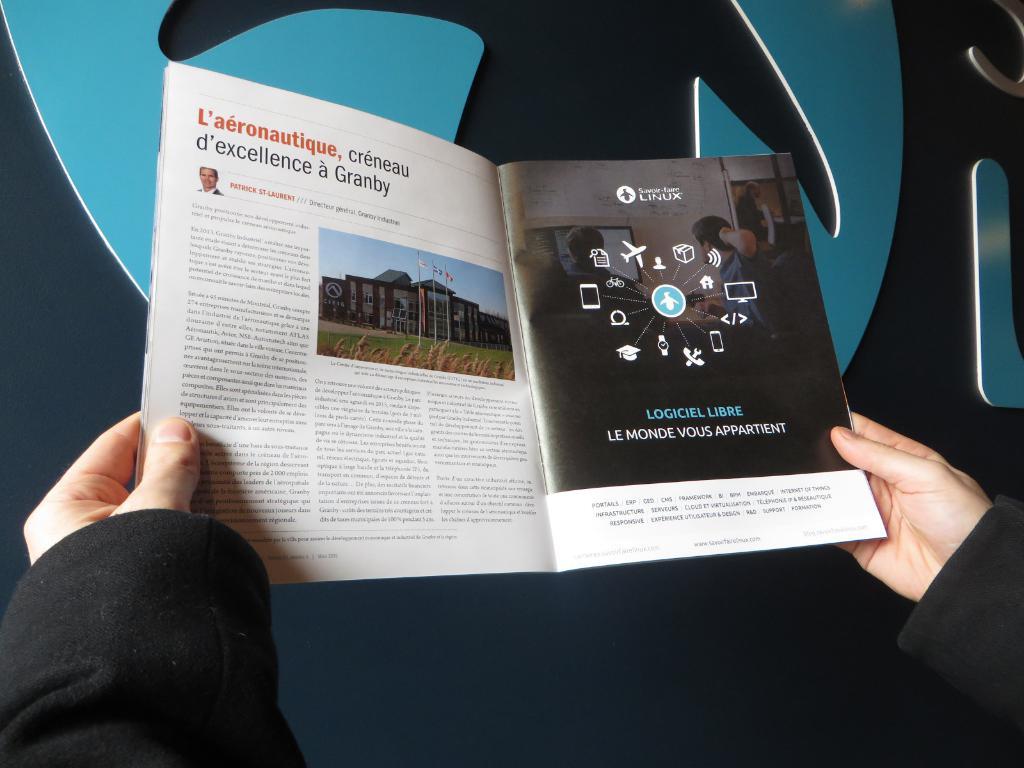What word is written in red on the page?
Offer a terse response. L'aeronautique. What company made the ad on the right?
Ensure brevity in your answer.  Linux. 